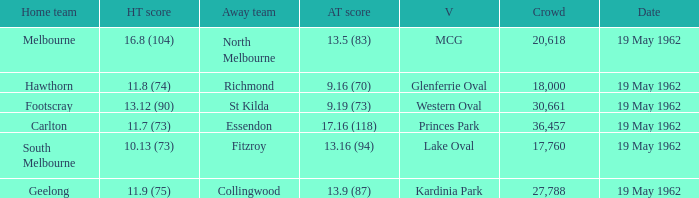What day is the venue the western oval? 19 May 1962. 